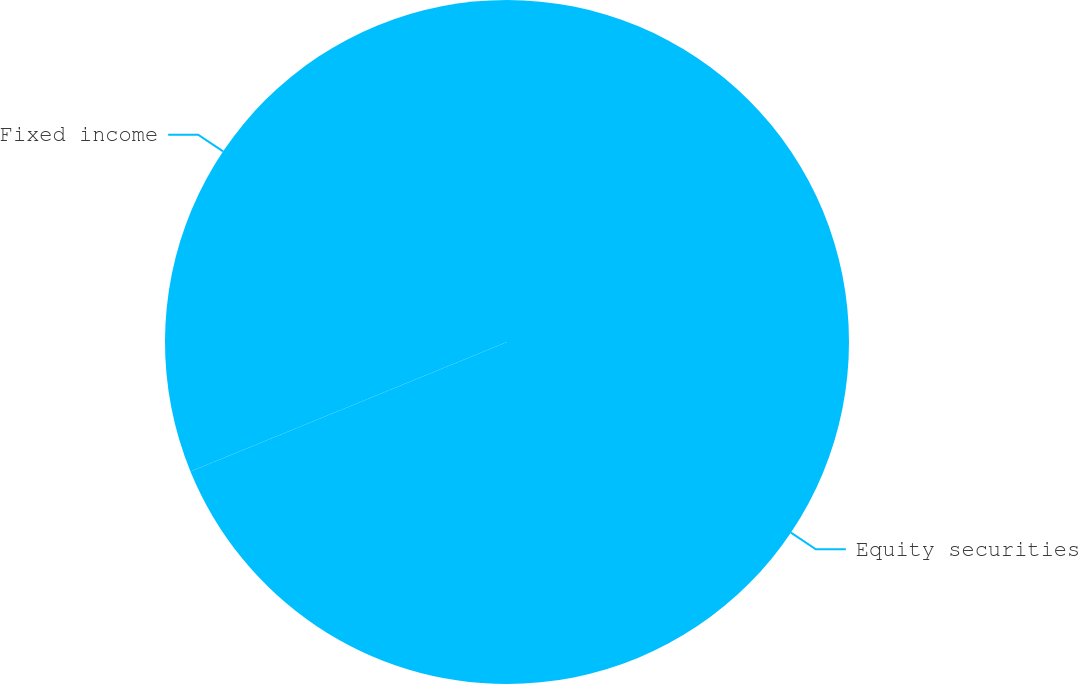Convert chart to OTSL. <chart><loc_0><loc_0><loc_500><loc_500><pie_chart><fcel>Equity securities<fcel>Fixed income<nl><fcel>68.82%<fcel>31.18%<nl></chart> 